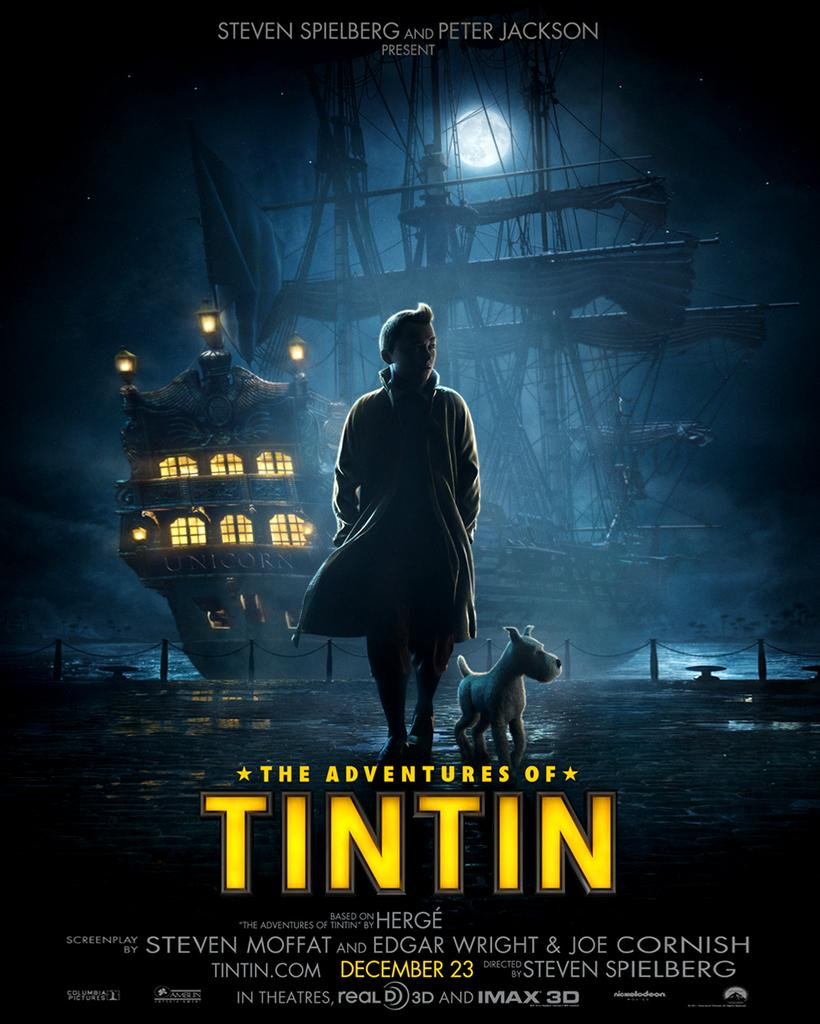<image>
Provide a brief description of the given image. a movie poster with the title 'the adventures of tintin' 